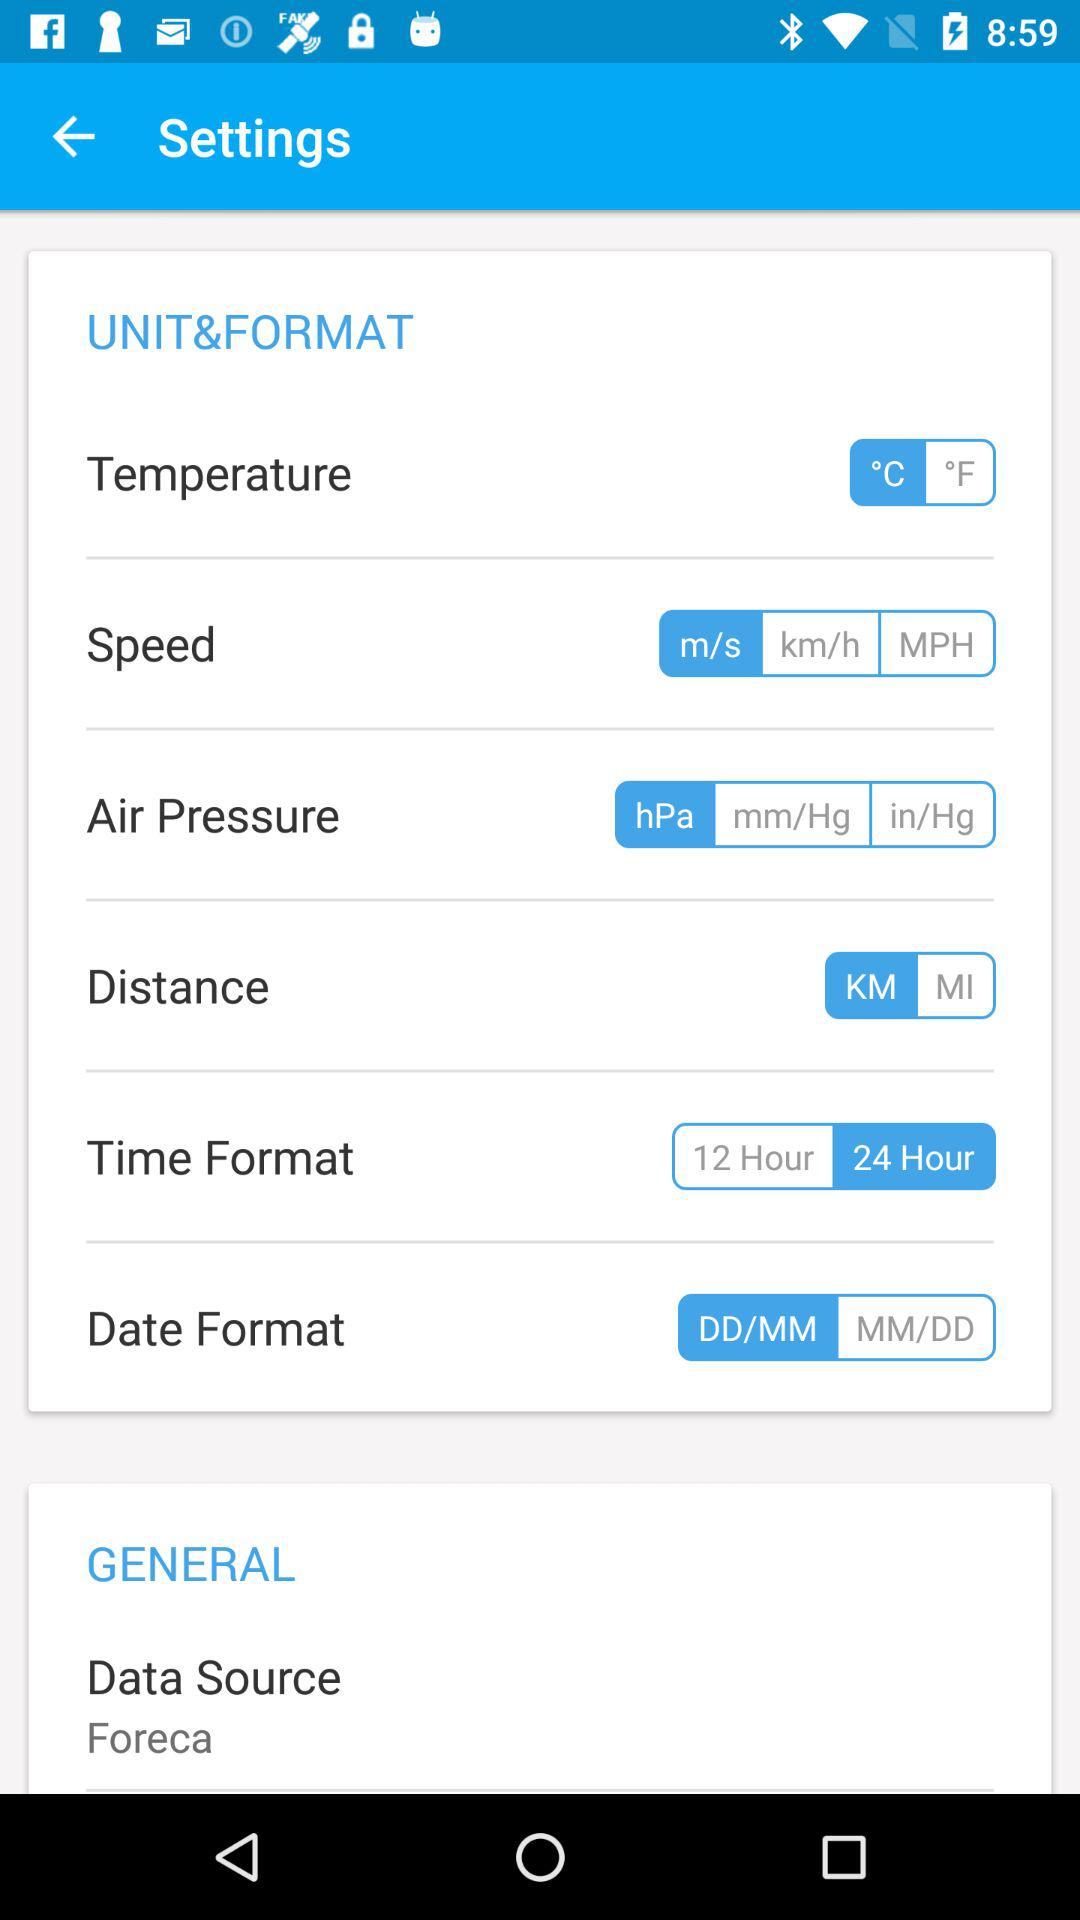Which time format is selected? The selected time format is "24 Hour". 